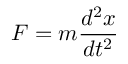<formula> <loc_0><loc_0><loc_500><loc_500>F = m { \frac { d ^ { 2 } x } { d t ^ { 2 } } }</formula> 